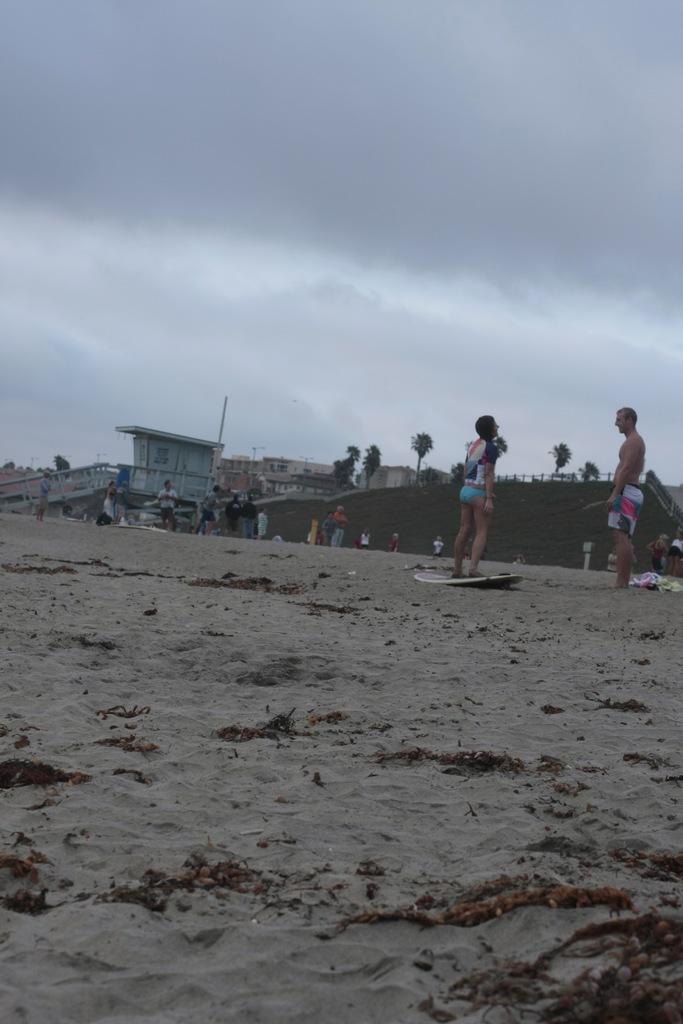In one or two sentences, can you explain what this image depicts? Sky is cloudy. This person is standing on a surfboard. We can see people, buildings and trees.  